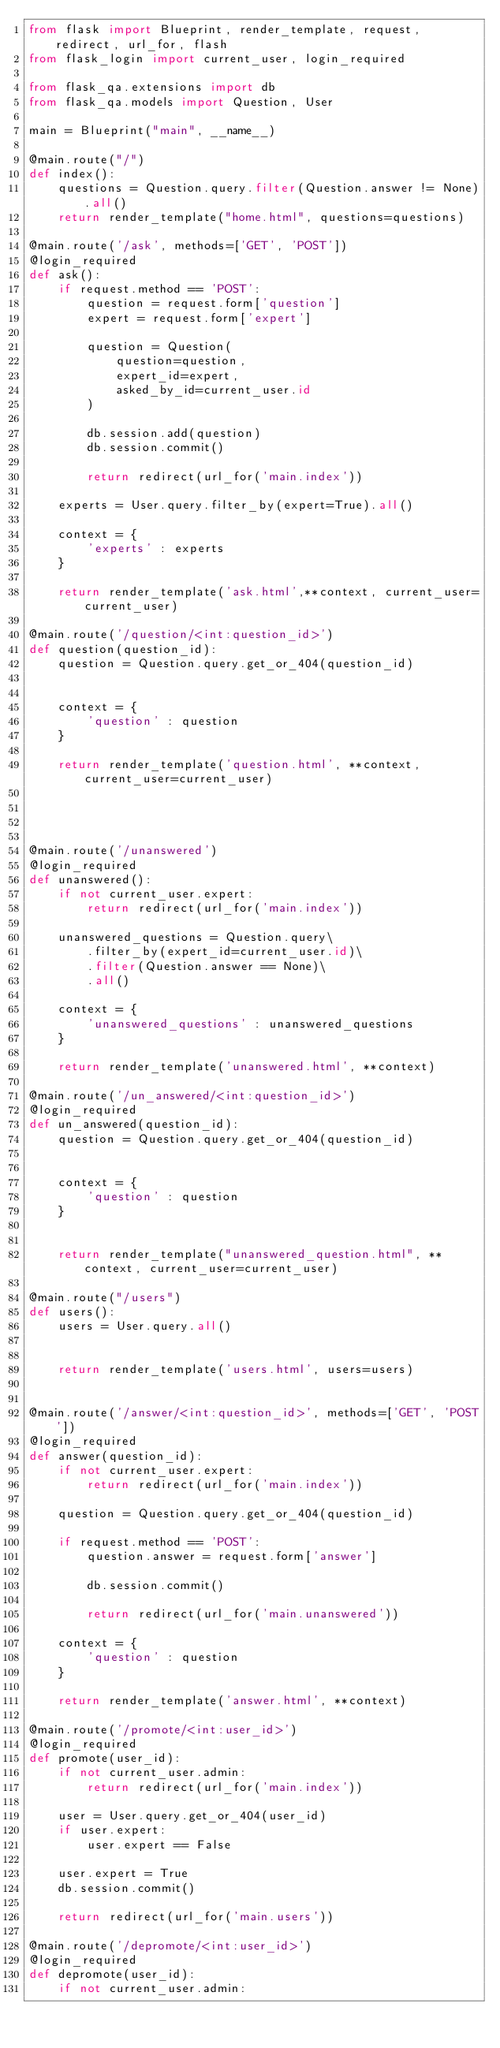<code> <loc_0><loc_0><loc_500><loc_500><_Python_>from flask import Blueprint, render_template, request, redirect, url_for, flash
from flask_login import current_user, login_required

from flask_qa.extensions import db
from flask_qa.models import Question, User

main = Blueprint("main", __name__)

@main.route("/")
def index():
    questions = Question.query.filter(Question.answer != None).all()
    return render_template("home.html", questions=questions)

@main.route('/ask', methods=['GET', 'POST'])
@login_required
def ask():
    if request.method == 'POST':
        question = request.form['question']
        expert = request.form['expert']

        question = Question(
            question=question, 
            expert_id=expert, 
            asked_by_id=current_user.id
        )

        db.session.add(question)
        db.session.commit()

        return redirect(url_for('main.index'))

    experts = User.query.filter_by(expert=True).all()

    context = {
        'experts' : experts
    }

    return render_template('ask.html',**context, current_user=current_user)

@main.route('/question/<int:question_id>')
def question(question_id):
    question = Question.query.get_or_404(question_id)


    context = {
        'question' : question
    }

    return render_template('question.html', **context, current_user=current_user)




@main.route('/unanswered')
@login_required
def unanswered():
    if not current_user.expert:
        return redirect(url_for('main.index'))

    unanswered_questions = Question.query\
        .filter_by(expert_id=current_user.id)\
        .filter(Question.answer == None)\
        .all()

    context = {
        'unanswered_questions' : unanswered_questions
    }

    return render_template('unanswered.html', **context)

@main.route('/un_answered/<int:question_id>')
@login_required
def un_answered(question_id):
    question = Question.query.get_or_404(question_id)


    context = {
        'question' : question
    }
    

    return render_template("unanswered_question.html", **context, current_user=current_user)

@main.route("/users")
def users():
    users = User.query.all()


    return render_template('users.html', users=users)


@main.route('/answer/<int:question_id>', methods=['GET', 'POST'])
@login_required
def answer(question_id):
    if not current_user.expert:
        return redirect(url_for('main.index'))

    question = Question.query.get_or_404(question_id)

    if request.method == 'POST':
        question.answer = request.form['answer']
        
        db.session.commit()

        return redirect(url_for('main.unanswered'))

    context = {
        'question' : question
    }

    return render_template('answer.html', **context)

@main.route('/promote/<int:user_id>')
@login_required
def promote(user_id):
    if not current_user.admin:
        return redirect(url_for('main.index'))

    user = User.query.get_or_404(user_id)
    if user.expert:
        user.expert == False

    user.expert = True 
    db.session.commit()

    return redirect(url_for('main.users'))

@main.route('/depromote/<int:user_id>')
@login_required
def depromote(user_id):
    if not current_user.admin:</code> 